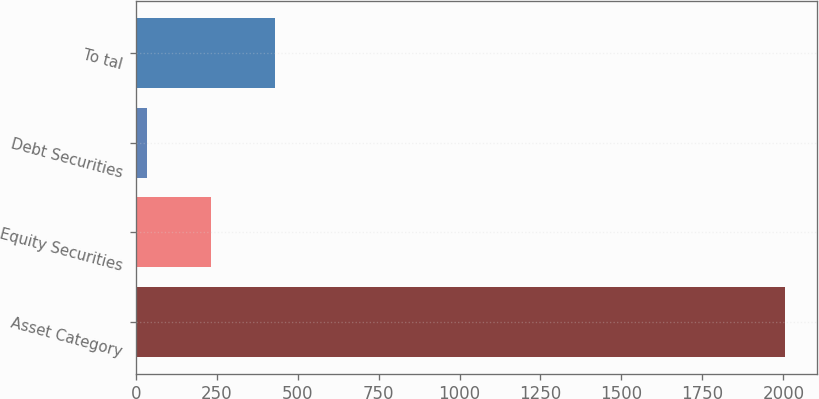Convert chart to OTSL. <chart><loc_0><loc_0><loc_500><loc_500><bar_chart><fcel>Asset Category<fcel>Equity Securities<fcel>Debt Securities<fcel>To tal<nl><fcel>2004<fcel>231.9<fcel>35<fcel>428.8<nl></chart> 